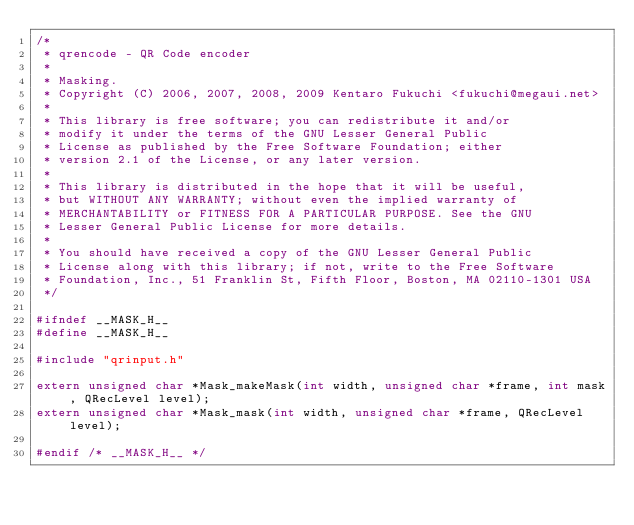Convert code to text. <code><loc_0><loc_0><loc_500><loc_500><_C_>/*
 * qrencode - QR Code encoder
 *
 * Masking.
 * Copyright (C) 2006, 2007, 2008, 2009 Kentaro Fukuchi <fukuchi@megaui.net>
 *
 * This library is free software; you can redistribute it and/or
 * modify it under the terms of the GNU Lesser General Public
 * License as published by the Free Software Foundation; either
 * version 2.1 of the License, or any later version.
 *
 * This library is distributed in the hope that it will be useful,
 * but WITHOUT ANY WARRANTY; without even the implied warranty of
 * MERCHANTABILITY or FITNESS FOR A PARTICULAR PURPOSE. See the GNU
 * Lesser General Public License for more details.
 *
 * You should have received a copy of the GNU Lesser General Public
 * License along with this library; if not, write to the Free Software
 * Foundation, Inc., 51 Franklin St, Fifth Floor, Boston, MA 02110-1301 USA
 */

#ifndef __MASK_H__
#define __MASK_H__

#include "qrinput.h"

extern unsigned char *Mask_makeMask(int width, unsigned char *frame, int mask, QRecLevel level);
extern unsigned char *Mask_mask(int width, unsigned char *frame, QRecLevel level);

#endif /* __MASK_H__ */
</code> 